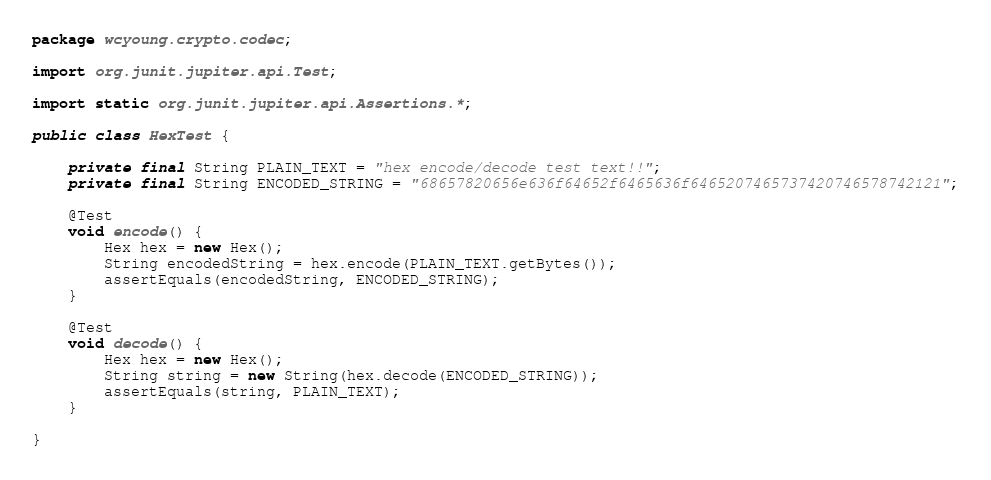<code> <loc_0><loc_0><loc_500><loc_500><_Java_>package wcyoung.crypto.codec;

import org.junit.jupiter.api.Test;

import static org.junit.jupiter.api.Assertions.*;

public class HexTest {

    private final String PLAIN_TEXT = "hex encode/decode test text!!";
    private final String ENCODED_STRING = "68657820656e636f64652f6465636f6465207465737420746578742121";

    @Test
    void encode() {
        Hex hex = new Hex();
        String encodedString = hex.encode(PLAIN_TEXT.getBytes());
        assertEquals(encodedString, ENCODED_STRING);
    }

    @Test
    void decode() {
        Hex hex = new Hex();
        String string = new String(hex.decode(ENCODED_STRING));
        assertEquals(string, PLAIN_TEXT);
    }

}
</code> 